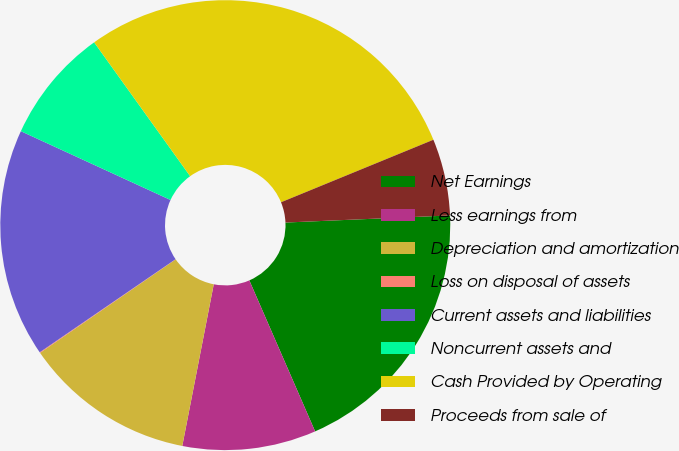Convert chart. <chart><loc_0><loc_0><loc_500><loc_500><pie_chart><fcel>Net Earnings<fcel>Less earnings from<fcel>Depreciation and amortization<fcel>Loss on disposal of assets<fcel>Current assets and liabilities<fcel>Noncurrent assets and<fcel>Cash Provided by Operating<fcel>Proceeds from sale of<nl><fcel>19.15%<fcel>9.6%<fcel>12.33%<fcel>0.05%<fcel>16.42%<fcel>8.24%<fcel>28.71%<fcel>5.51%<nl></chart> 